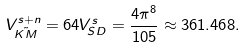Convert formula to latex. <formula><loc_0><loc_0><loc_500><loc_500>V _ { \tilde { K M } } ^ { s + n } = 6 4 V _ { S D } ^ { s } = \frac { 4 \pi ^ { 8 } } { 1 0 5 } \approx 3 6 1 . 4 6 8 .</formula> 